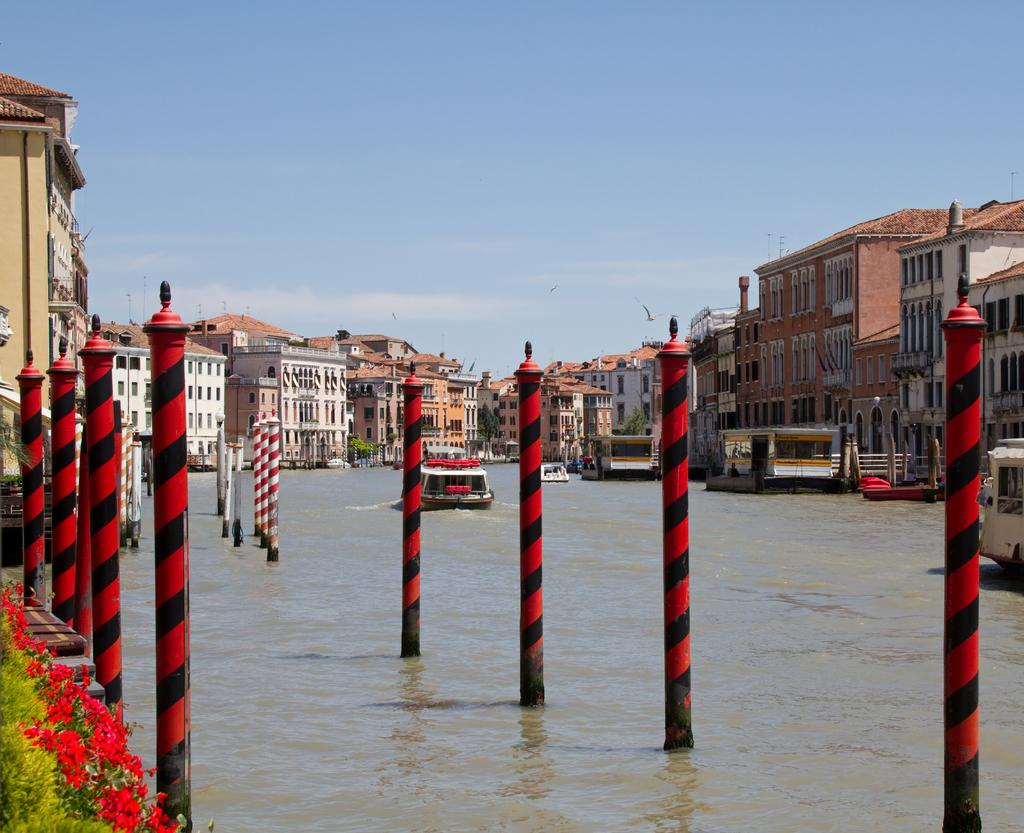What structures are present in the image? There are poles and buildings with windows in the image. What natural elements can be seen in the image? There are flowers and water with boats in the image. What is visible in the background of the image? The sky is visible in the background of the image. Can you describe any objects in the image? There are some objects in the image, but their specific details are not mentioned in the facts. How many geese are flying over the party in the image? There is no party or geese present in the image. What type of lead is used to connect the poles in the image? There is no mention of lead or how the poles are connected in the image. 